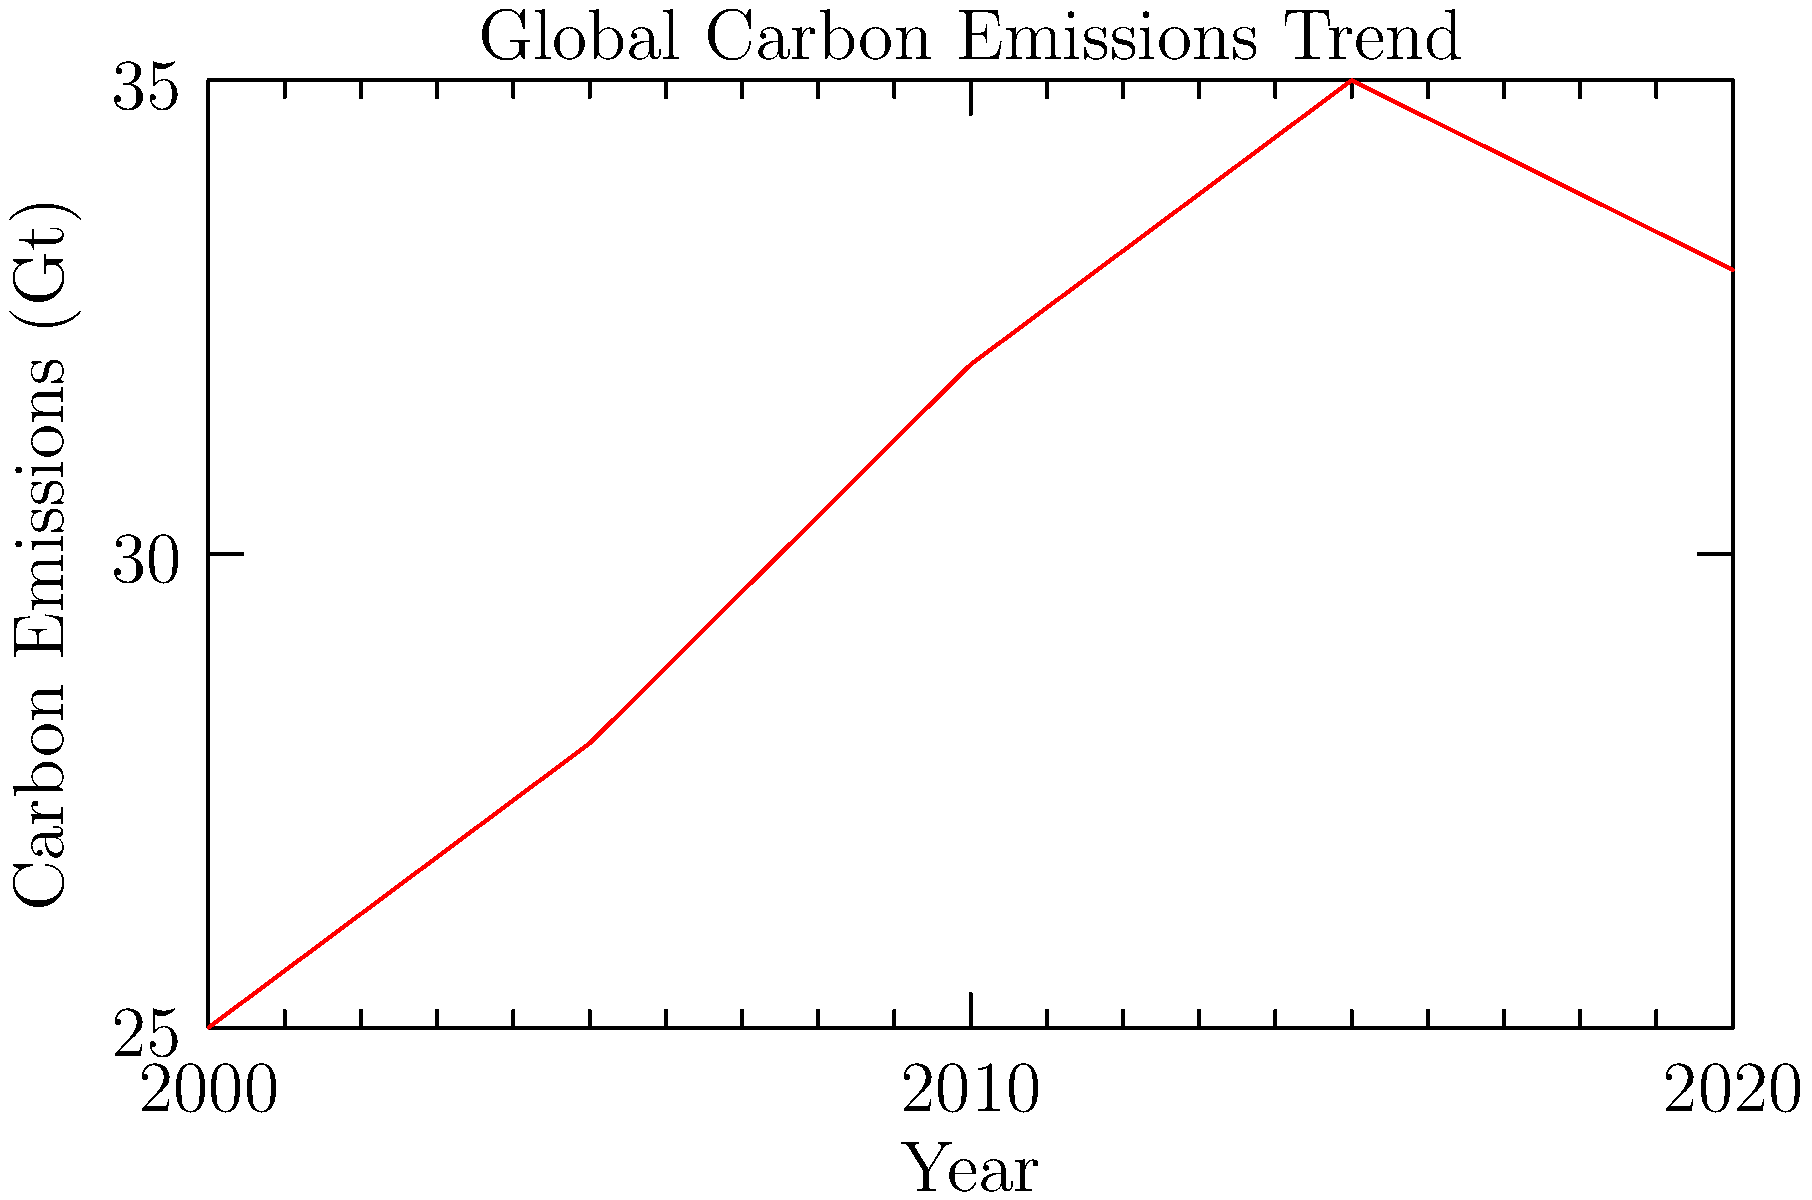Based on the line graph showing global carbon emission trends from 2000 to 2020, what significant change occurred between 2015 and 2020 that an environmental advocate might find relevant for a FOIA request? To answer this question, let's analyze the graph step-by-step:

1. Observe the overall trend from 2000 to 2015:
   - The line shows a steady increase in carbon emissions.
   - This trend continues from approximately 25 Gt in 2000 to 35 Gt in 2015.

2. Examine the period between 2015 and 2020:
   - There's a noticeable change in the trend.
   - The line shows a decrease from about 35 Gt in 2015 to 33 Gt in 2020.

3. Interpret this change:
   - This represents the first significant decrease in emissions over the 20-year period shown.
   - It suggests a potential shift in global carbon emission patterns or policies.

4. Consider the environmental advocate's perspective:
   - This decrease would be of great interest to an environmental advocate.
   - It may indicate the implementation of new environmental policies or technological advancements.

5. Relevance for a FOIA request:
   - An environmental advocate might want to investigate the causes of this decrease.
   - A FOIA request could be used to obtain government documents related to emission reduction strategies, policy changes, or international agreements implemented during this period.

The significant change between 2015 and 2020 is the decrease in carbon emissions, which is noteworthy for an environmental advocate seeking information through a FOIA request.
Answer: Decrease in carbon emissions 